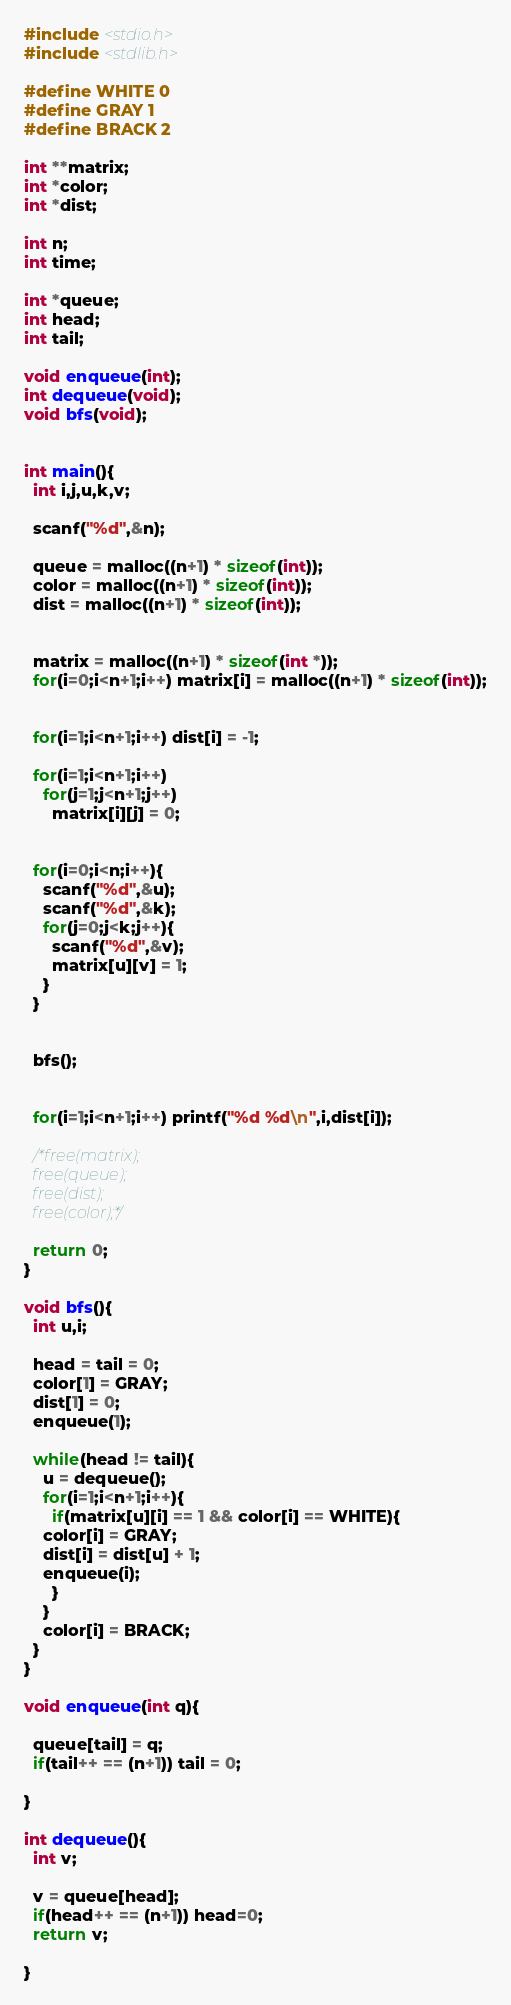<code> <loc_0><loc_0><loc_500><loc_500><_C_>#include <stdio.h>
#include <stdlib.h>

#define WHITE 0
#define GRAY 1
#define BRACK 2

int **matrix;
int *color;
int *dist;

int n;
int time;

int *queue;
int head;
int tail;

void enqueue(int);
int dequeue(void);
void bfs(void);


int main(){
  int i,j,u,k,v;

  scanf("%d",&n);

  queue = malloc((n+1) * sizeof(int));
  color = malloc((n+1) * sizeof(int));
  dist = malloc((n+1) * sizeof(int));
 
  
  matrix = malloc((n+1) * sizeof(int *));
  for(i=0;i<n+1;i++) matrix[i] = malloc((n+1) * sizeof(int));


  for(i=1;i<n+1;i++) dist[i] = -1;
  
  for(i=1;i<n+1;i++)
    for(j=1;j<n+1;j++)
      matrix[i][j] = 0;
  
  
  for(i=0;i<n;i++){
    scanf("%d",&u);
    scanf("%d",&k);
    for(j=0;j<k;j++){
      scanf("%d",&v);
      matrix[u][v] = 1;
    }
  }


  bfs();
 

  for(i=1;i<n+1;i++) printf("%d %d\n",i,dist[i]);

  /*free(matrix);
  free(queue);
  free(dist);
  free(color);*/

  return 0;
}

void bfs(){
  int u,i;

  head = tail = 0;
  color[1] = GRAY;
  dist[1] = 0;
  enqueue(1);
  
  while(head != tail){
    u = dequeue();
    for(i=1;i<n+1;i++){
      if(matrix[u][i] == 1 && color[i] == WHITE){
	color[i] = GRAY;
	dist[i] = dist[u] + 1;
	enqueue(i);
      }
    }
    color[i] = BRACK;
  }
}

void enqueue(int q){
  
  queue[tail] = q;
  if(tail++ == (n+1)) tail = 0;
  
}

int dequeue(){
  int v;
  
  v = queue[head];
  if(head++ == (n+1)) head=0;
  return v;

}</code> 